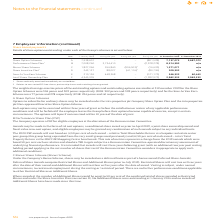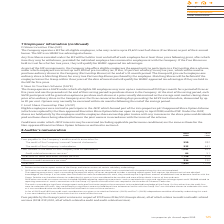According to Intu Properties's financial document, What is the weighted average exercise prices of the outstanding options at 31 December 2019 for the Share Option Schemes? According to the financial document, 304 pence. The relevant text states: "1 December 2019 for the Share Option Schemes were 304 pence and 309 pence respectively (2018: 302 pence and 309 pence respectively) and for the Save As You Ear..." Also, When will the options lapse? if not exercised within 10 years of the date of grant. The document states: "in certain circumstances. The options will lapse if not exercised within 10 years of the date of grant...." Also, What is the weighted average exercise prices of the outstanding options exercisable at 31 December 2019 for the Save As You Earn Scheme? According to the financial document, 278. The relevant text states: "mance Share Plan 1 B 7,008,260 3,734,410 – (2,228,278) 8,514,392 n/a..." Also, can you calculate: What is the percentage change in the outstanding shares under the share options scheme from 1 January 2019 to 31 December 2019? To answer this question, I need to perform calculations using the financial data. The calculation is: (7,137,073-7,938,601)/7,938,601, which equals -10.1 (percentage). This is based on the information: "Share Option Schemes A 7,938,601 – – (801,528) 7,137,073 5,687,073 Share Option Schemes A 7,938,601 – – (801,528) 7,137,073 5,687,073..." The key data points involved are: 7,137,073, 7,938,601. Also, can you calculate: What is the percentage change in the outstanding shares under the performance share plan from 1 January 2019 to 31 December 2019? To answer this question, I need to perform calculations using the financial data. The calculation is: (8,514,392-7,008,260)/7,008,260, which equals 21.49 (percentage). This is based on the information: "Performance Share Plan 1 B 7,008,260 3,734,410 – (2,228,278) 8,514,392 n/a Share Plan 1 B 7,008,260 3,734,410 – (2,228,278) 8,514,392 n/a..." The key data points involved are: 7,008,260, 8,514,392. Also, can you calculate: What is the percentage change in the outstanding shares under the Save As You Earn Scheme from 1 January 2019 to 31 December 2019? To answer this question, I need to perform calculations using the financial data. The calculation is: (546,332-219,136)/219,136, which equals 149.31 (percentage). This is based on the information: "As You Earn Scheme E 219,136 448,368 – (121,172) 546,332 60,443 Save As You Earn Scheme E 219,136 448,368 – (121,172) 546,332 60,443..." The key data points involved are: 219,136, 546,332. 